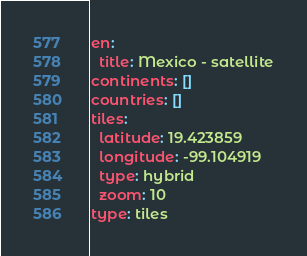<code> <loc_0><loc_0><loc_500><loc_500><_YAML_>en:
  title: Mexico - satellite
continents: []
countries: []
tiles:
  latitude: 19.423859
  longitude: -99.104919
  type: hybrid
  zoom: 10
type: tiles
</code> 